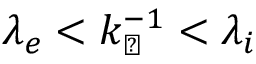Convert formula to latex. <formula><loc_0><loc_0><loc_500><loc_500>\lambda _ { e } < k _ { \perp } ^ { - 1 } < \lambda _ { i }</formula> 